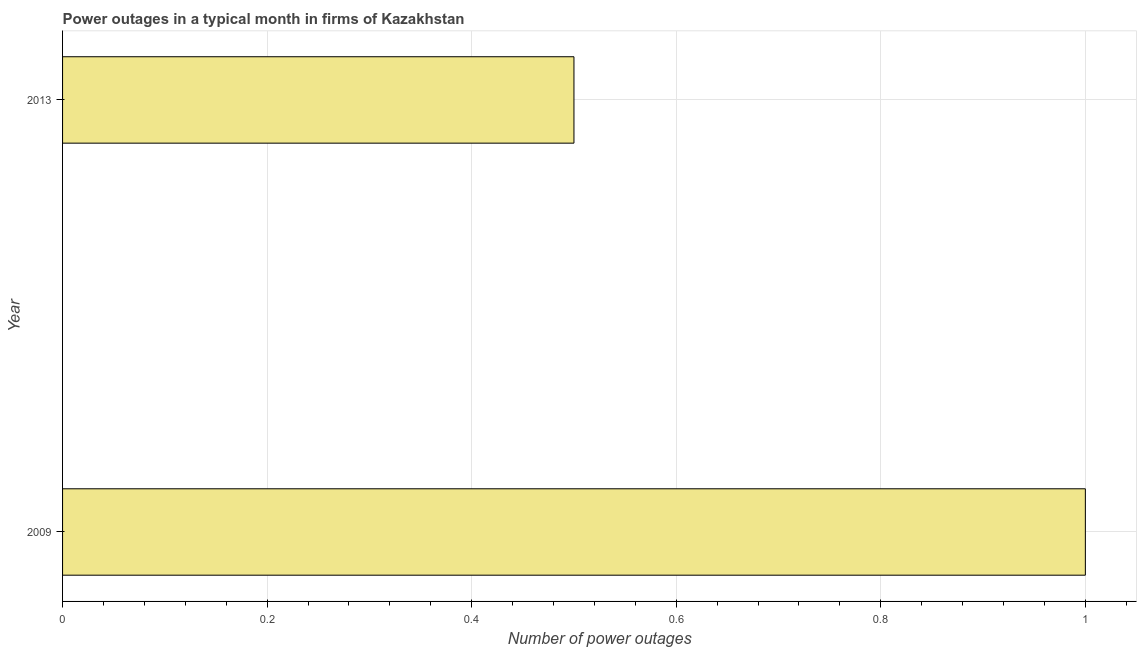Does the graph contain any zero values?
Your answer should be compact. No. Does the graph contain grids?
Keep it short and to the point. Yes. What is the title of the graph?
Ensure brevity in your answer.  Power outages in a typical month in firms of Kazakhstan. What is the label or title of the X-axis?
Offer a terse response. Number of power outages. Across all years, what is the maximum number of power outages?
Give a very brief answer. 1. Across all years, what is the minimum number of power outages?
Offer a terse response. 0.5. In which year was the number of power outages maximum?
Offer a terse response. 2009. In how many years, is the number of power outages greater than 0.92 ?
Your response must be concise. 1. What is the ratio of the number of power outages in 2009 to that in 2013?
Your answer should be compact. 2. In how many years, is the number of power outages greater than the average number of power outages taken over all years?
Keep it short and to the point. 1. How many bars are there?
Offer a very short reply. 2. Are all the bars in the graph horizontal?
Provide a succinct answer. Yes. How many years are there in the graph?
Your response must be concise. 2. What is the difference between two consecutive major ticks on the X-axis?
Your answer should be compact. 0.2. What is the Number of power outages in 2009?
Provide a short and direct response. 1. What is the Number of power outages of 2013?
Keep it short and to the point. 0.5. What is the ratio of the Number of power outages in 2009 to that in 2013?
Keep it short and to the point. 2. 